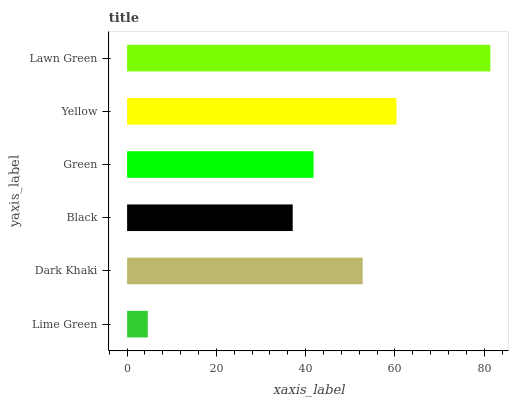Is Lime Green the minimum?
Answer yes or no. Yes. Is Lawn Green the maximum?
Answer yes or no. Yes. Is Dark Khaki the minimum?
Answer yes or no. No. Is Dark Khaki the maximum?
Answer yes or no. No. Is Dark Khaki greater than Lime Green?
Answer yes or no. Yes. Is Lime Green less than Dark Khaki?
Answer yes or no. Yes. Is Lime Green greater than Dark Khaki?
Answer yes or no. No. Is Dark Khaki less than Lime Green?
Answer yes or no. No. Is Dark Khaki the high median?
Answer yes or no. Yes. Is Green the low median?
Answer yes or no. Yes. Is Yellow the high median?
Answer yes or no. No. Is Black the low median?
Answer yes or no. No. 